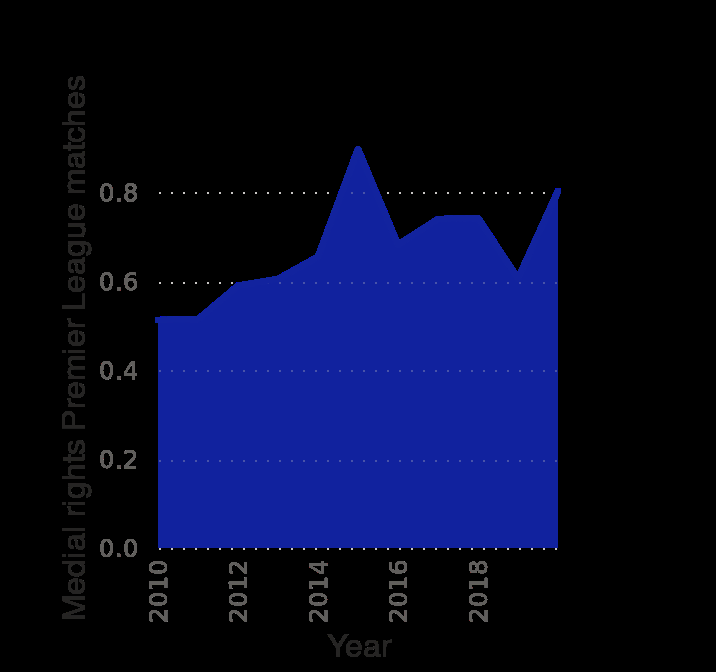<image>
What is the range of the x-axis on the Manchester United distribution of broadcasting revenue diagram? The x-axis has a minimum value of 2010 and a maximum value of 2018. In which year did the medial rights drop significantly? The medial rights dropped significantly in 2016. Is there an overall trend in the medial rights from 2010 to 2020? Yes, there is an overall increasing trend in the medial rights from 2010 to 2020. What is the name of the football league mentioned in the diagram? The diagram refers to the Premier League matches. 